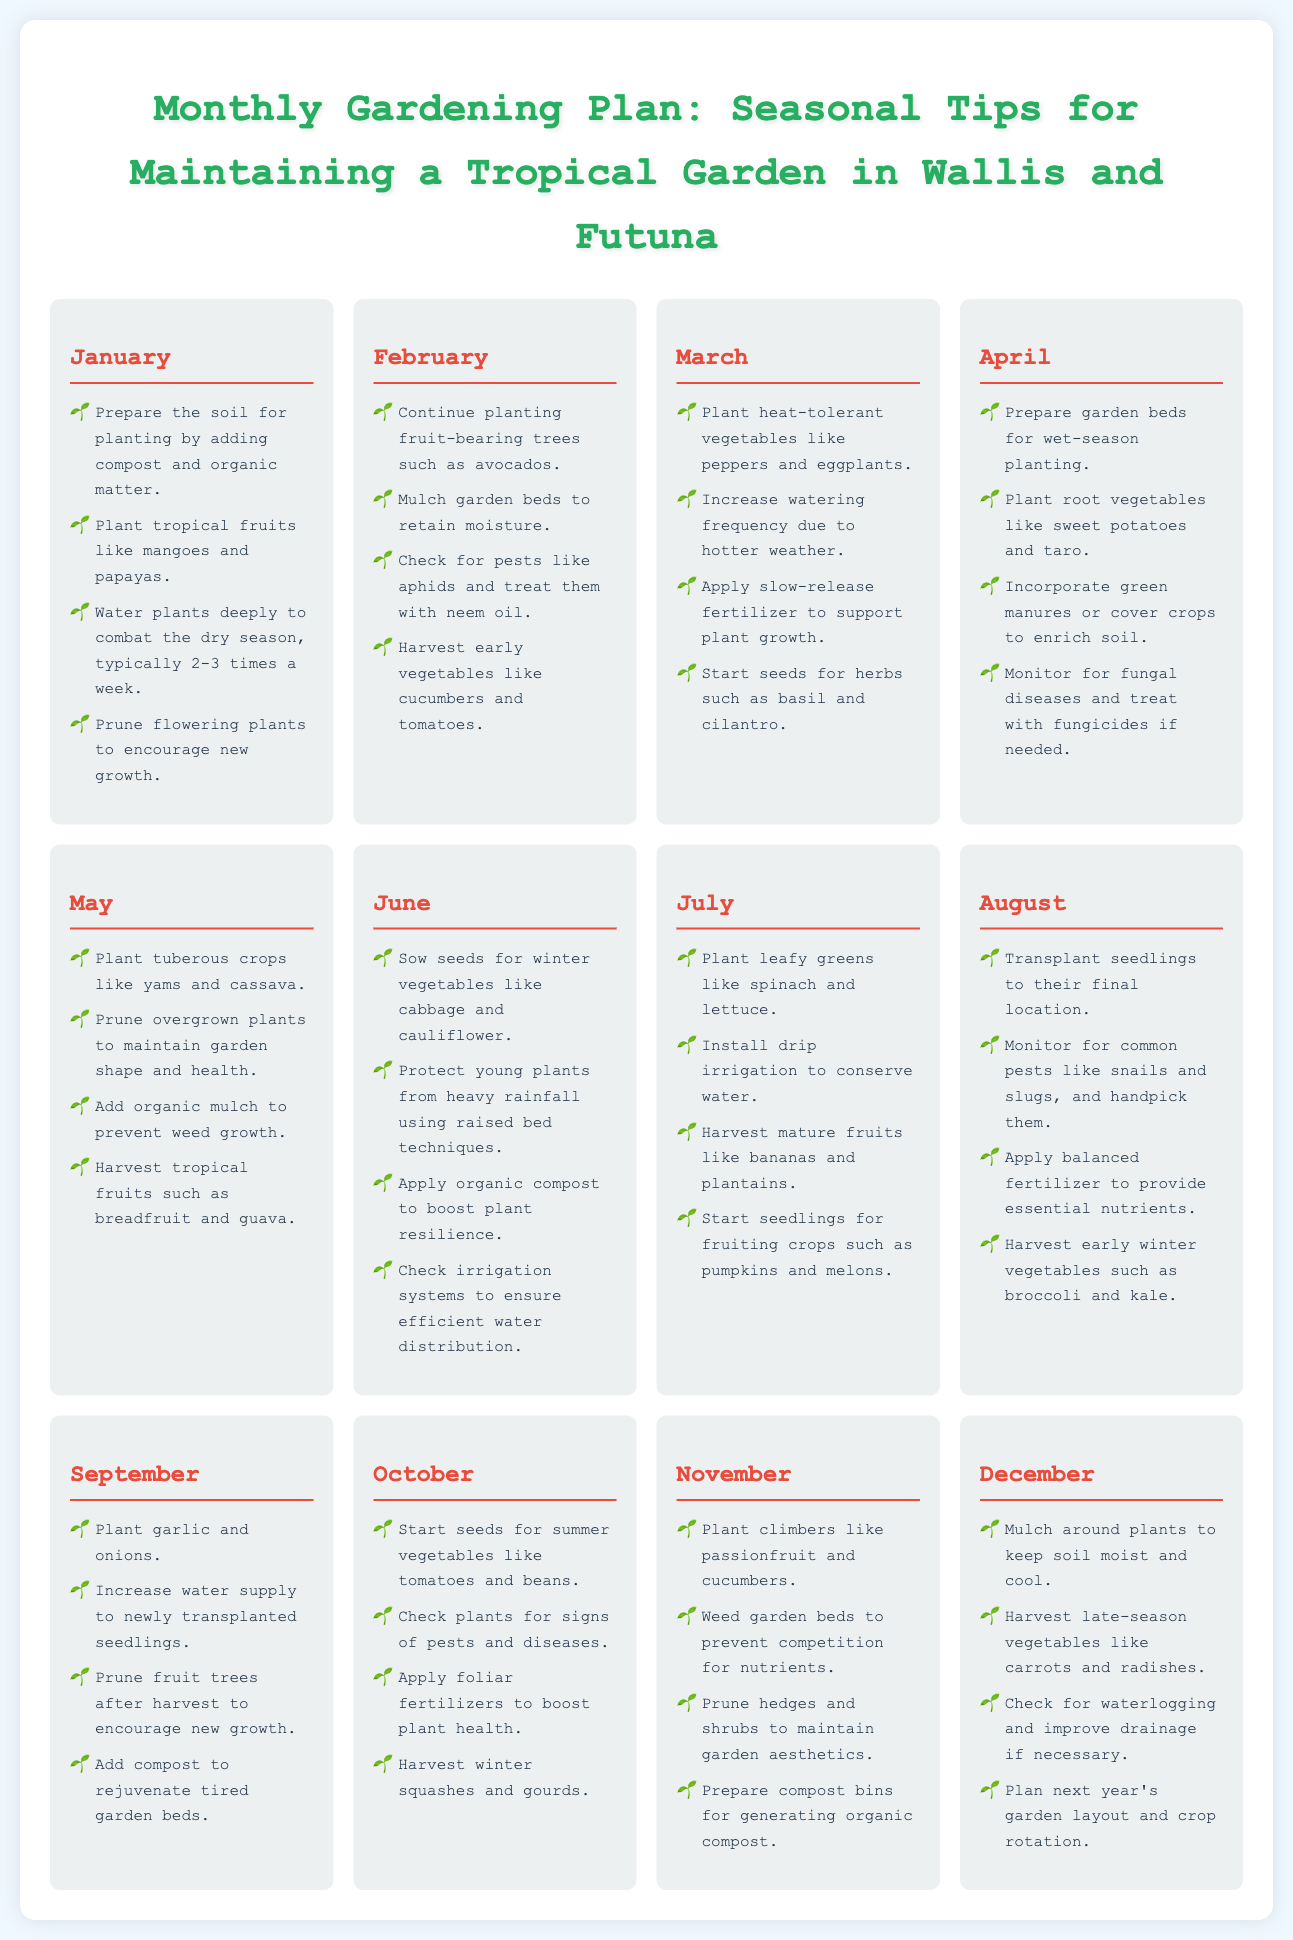what should be done in January for soil preparation? In January, the soil should be prepared for planting by adding compost and organic matter.
Answer: adding compost and organic matter which month suggests planting leafy greens? July is the month suggested for planting leafy greens.
Answer: July what type of vegetables should be planted in March? In March, heat-tolerant vegetables like peppers and eggplants should be planted.
Answer: peppers and eggplants how often should plants be watered in January? Plants should be watered deeply 2-3 times a week in January.
Answer: 2-3 times a week what should be checked in February for pest control? In February, one should check for pests like aphids and treat them with neem oil.
Answer: aphids which fruit is harvested in May? In May, tropical fruits such as breadfruit and guava are harvested.
Answer: breadfruit and guava what task is recommended for soil in September? In September, adding compost to rejuvenate tired garden beds is recommended.
Answer: adding compost when should seedlings be transplanted? Seedlings should be transplanted in August.
Answer: August what is commonly checked for in October? In October, plants are checked for signs of pests and diseases.
Answer: pests and diseases 